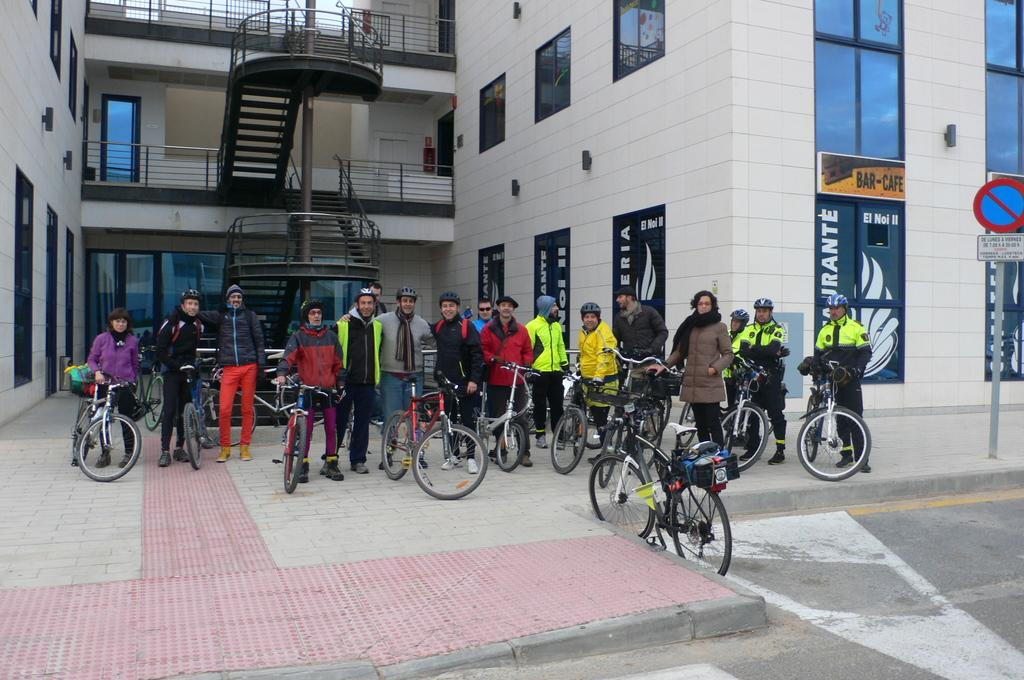Who or what can be seen in the image? There are persons in the image. What objects are associated with the persons in the image? There are cycles in the image. Where are the cycles located in relation to the building? The cycles are in front of a building. What architectural feature is present in the middle of the image? There are stairs in the middle of the image. What is located on the right side of the image? There is a sign board on the right side of the image. What type of camera can be seen in the image? There is no camera present in the image. What kind of drug is being sold on the sign board in the image? There is no drug mentioned or depicted on the sign board in the image. 